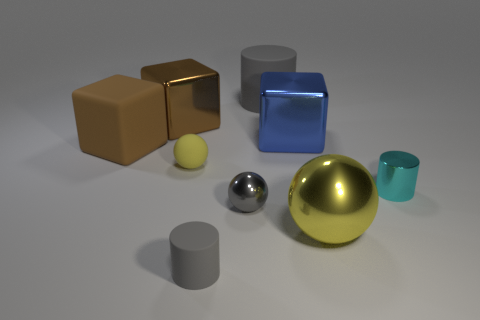Subtract all balls. How many objects are left? 6 Add 4 purple cylinders. How many purple cylinders exist? 4 Subtract 0 red cylinders. How many objects are left? 9 Subtract all blue matte balls. Subtract all tiny objects. How many objects are left? 5 Add 4 small metal spheres. How many small metal spheres are left? 5 